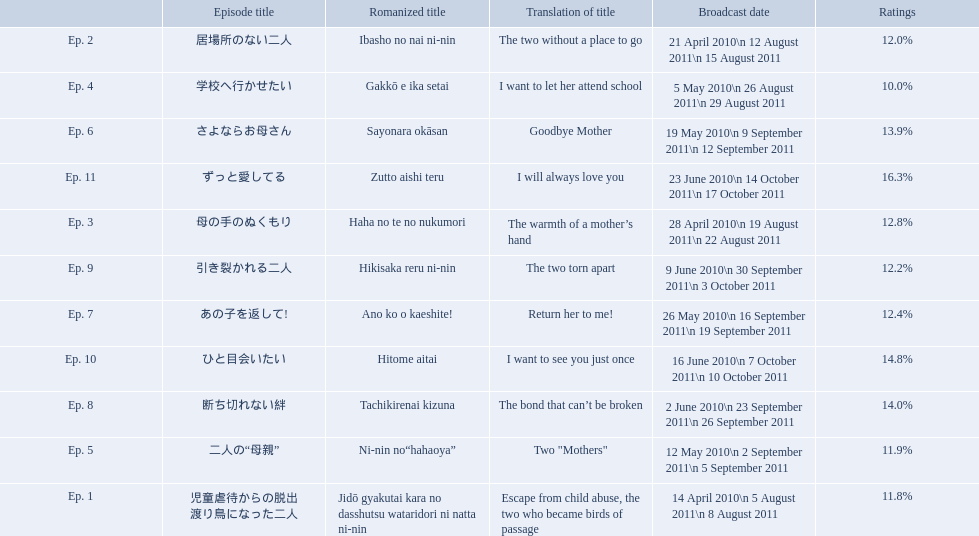What are all the episodes? Ep. 1, Ep. 2, Ep. 3, Ep. 4, Ep. 5, Ep. 6, Ep. 7, Ep. 8, Ep. 9, Ep. 10, Ep. 11. Of these, which ones have a rating of 14%? Ep. 8, Ep. 10. Of these, which one is not ep. 10? Ep. 8. What are the episode numbers? Ep. 1, Ep. 2, Ep. 3, Ep. 4, Ep. 5, Ep. 6, Ep. 7, Ep. 8, Ep. 9, Ep. 10, Ep. 11. What was the percentage of total ratings for episode 8? 14.0%. What are all of the episode numbers? Ep. 1, Ep. 2, Ep. 3, Ep. 4, Ep. 5, Ep. 6, Ep. 7, Ep. 8, Ep. 9, Ep. 10, Ep. 11. And their titles? 児童虐待からの脱出 渡り鳥になった二人, 居場所のない二人, 母の手のぬくもり, 学校へ行かせたい, 二人の“母親”, さよならお母さん, あの子を返して!, 断ち切れない絆, 引き裂かれる二人, ひと目会いたい, ずっと愛してる. What about their translated names? Escape from child abuse, the two who became birds of passage, The two without a place to go, The warmth of a mother’s hand, I want to let her attend school, Two "Mothers", Goodbye Mother, Return her to me!, The bond that can’t be broken, The two torn apart, I want to see you just once, I will always love you. Which episode number's title translated to i want to let her attend school? Ep. 4. 